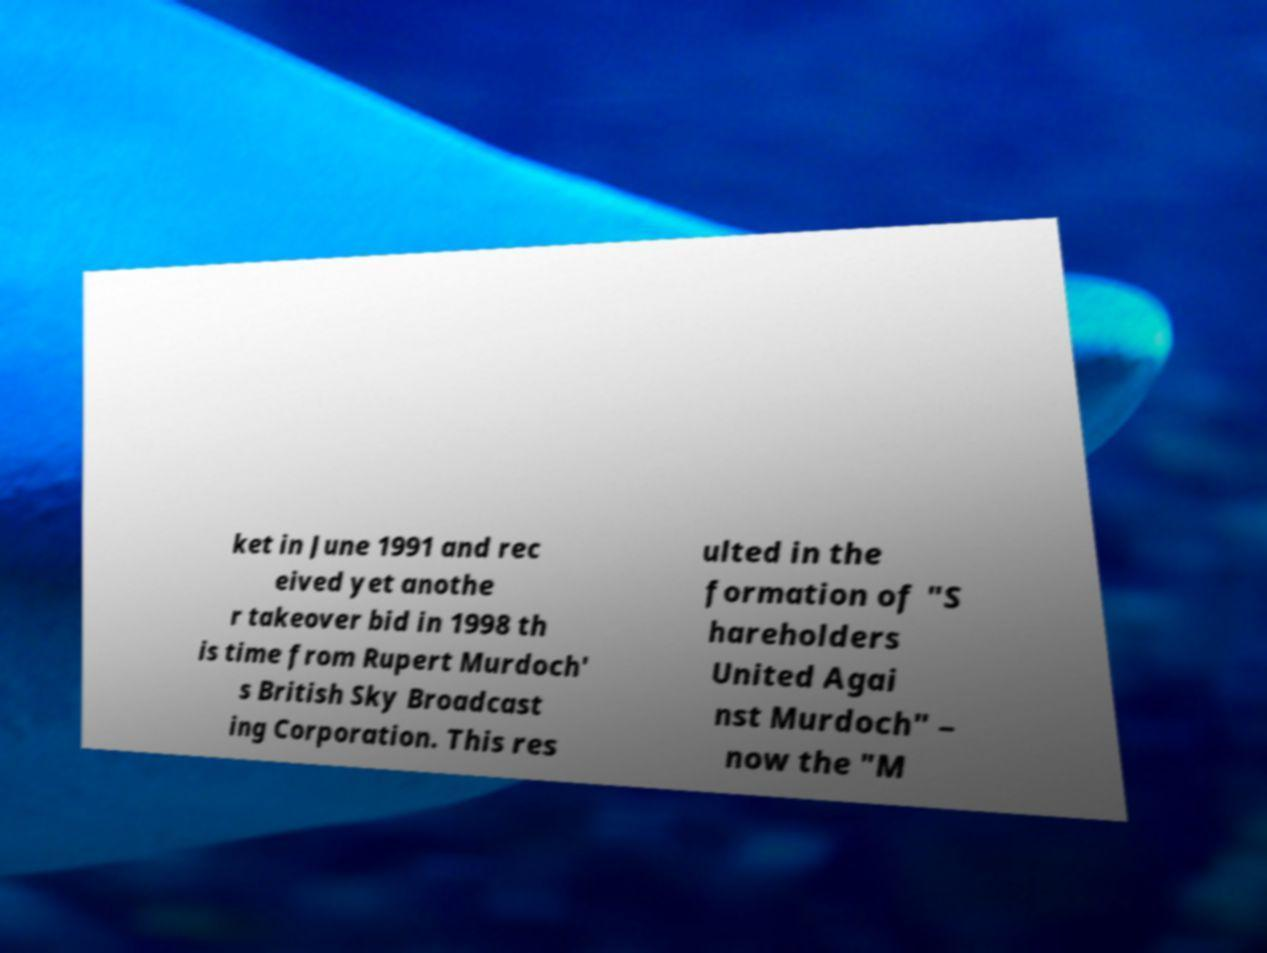Can you read and provide the text displayed in the image?This photo seems to have some interesting text. Can you extract and type it out for me? ket in June 1991 and rec eived yet anothe r takeover bid in 1998 th is time from Rupert Murdoch' s British Sky Broadcast ing Corporation. This res ulted in the formation of "S hareholders United Agai nst Murdoch" – now the "M 